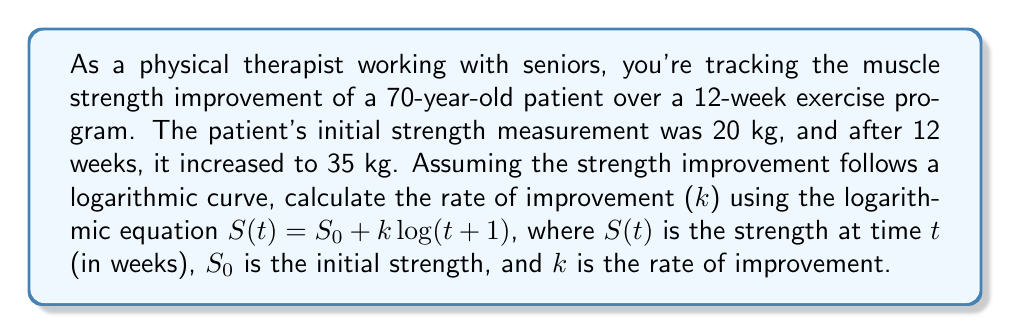Help me with this question. To solve this problem, we'll use the logarithmic equation for strength improvement:

$$S(t) = S_0 + k \log(t+1)$$

We know the following:
- Initial strength, $S_0 = 20$ kg
- Final strength after 12 weeks, $S(12) = 35$ kg
- Time, $t = 12$ weeks

Let's substitute these values into the equation:

$$35 = 20 + k \log(12+1)$$

Now, we need to solve for k:

1) Subtract 20 from both sides:
   $$15 = k \log(13)$$

2) Divide both sides by $\log(13)$:
   $$k = \frac{15}{\log(13)}$$

3) Calculate $\log(13)$ (we'll use base 10 logarithm):
   $$\log(13) \approx 1.1139$$

4) Calculate k:
   $$k = \frac{15}{1.1139} \approx 13.4662$$

Therefore, the rate of improvement (k) is approximately 13.4662 kg per log-week.
Answer: $k \approx 13.4662$ kg per log-week 